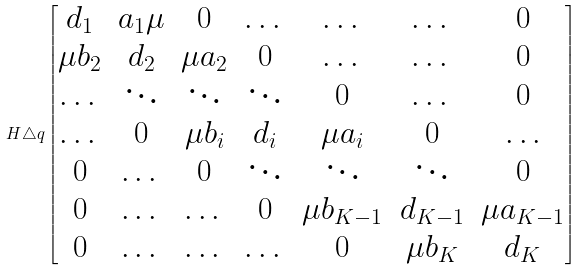Convert formula to latex. <formula><loc_0><loc_0><loc_500><loc_500>H \triangle q \begin{bmatrix} d _ { 1 } & a _ { 1 } \mu & 0 & \dots & \dots & \dots & 0 \\ \mu b _ { 2 } & d _ { 2 } & \mu a _ { 2 } & 0 & \dots & \dots & 0 \\ \dots & \ddots & \ddots & \ddots & 0 & \dots & 0 \\ \dots & 0 & \mu b _ { i } & d _ { i } & \mu a _ { i } & 0 & \dots \\ 0 & \dots & 0 & \ddots & \ddots & \ddots & 0 \\ 0 & \dots & \dots & 0 & \mu b _ { K - 1 } & d _ { K - 1 } & \mu a _ { K - 1 } \\ 0 & \dots & \dots & \dots & 0 & \mu b _ { K } & d _ { K } \\ \end{bmatrix}</formula> 